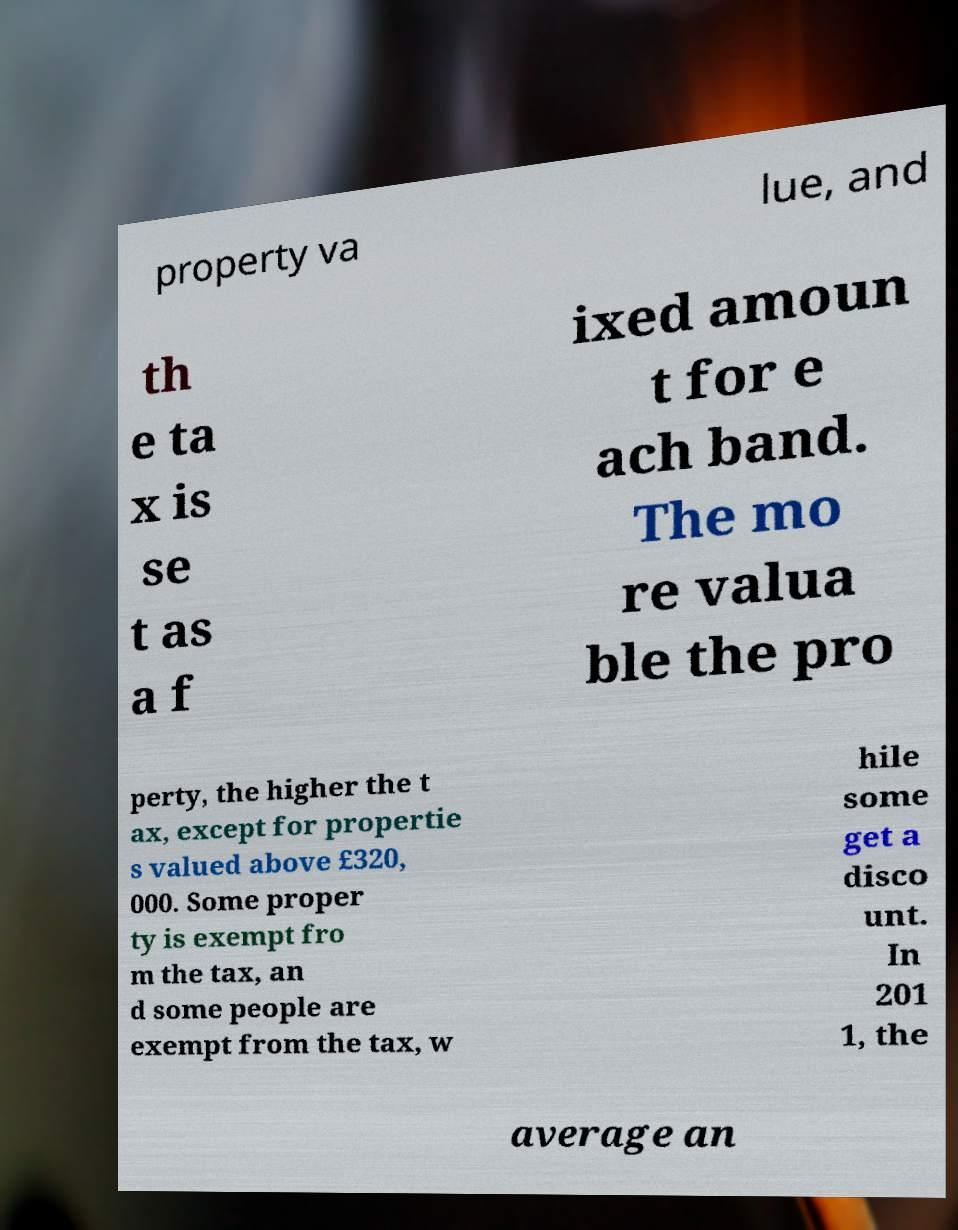Please identify and transcribe the text found in this image. property va lue, and th e ta x is se t as a f ixed amoun t for e ach band. The mo re valua ble the pro perty, the higher the t ax, except for propertie s valued above £320, 000. Some proper ty is exempt fro m the tax, an d some people are exempt from the tax, w hile some get a disco unt. In 201 1, the average an 